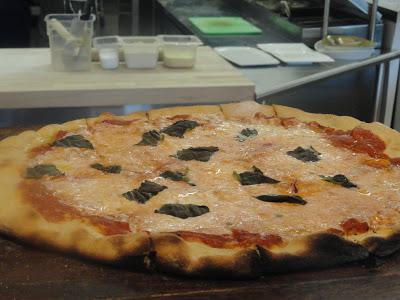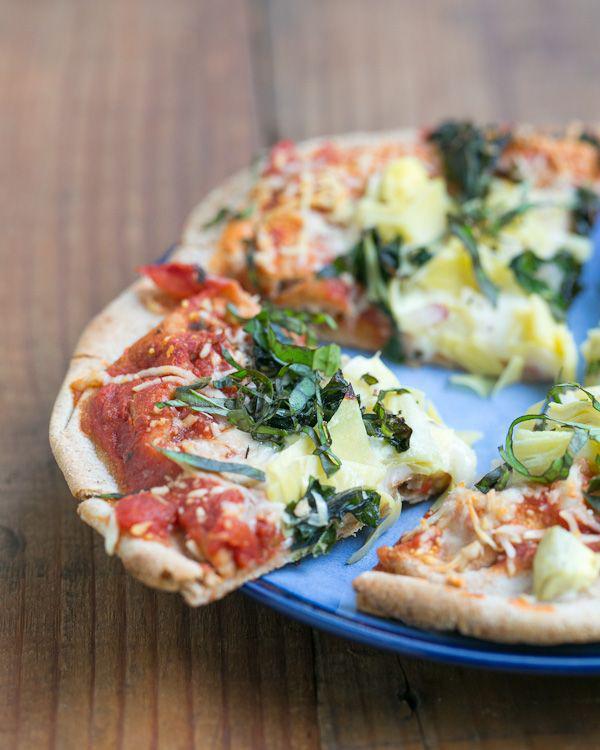The first image is the image on the left, the second image is the image on the right. Evaluate the accuracy of this statement regarding the images: "At least one of the pizzas contains pepperoni.". Is it true? Answer yes or no. No. 